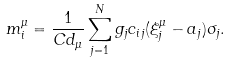<formula> <loc_0><loc_0><loc_500><loc_500>m _ { i } ^ { \mu } = \frac { 1 } { C d _ { \mu } } \sum _ { j = 1 } ^ { N } g _ { j } c _ { i j } ( \xi _ { j } ^ { \mu } - a _ { j } ) \sigma _ { j } .</formula> 